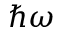Convert formula to latex. <formula><loc_0><loc_0><loc_500><loc_500>\hbar { \omega }</formula> 